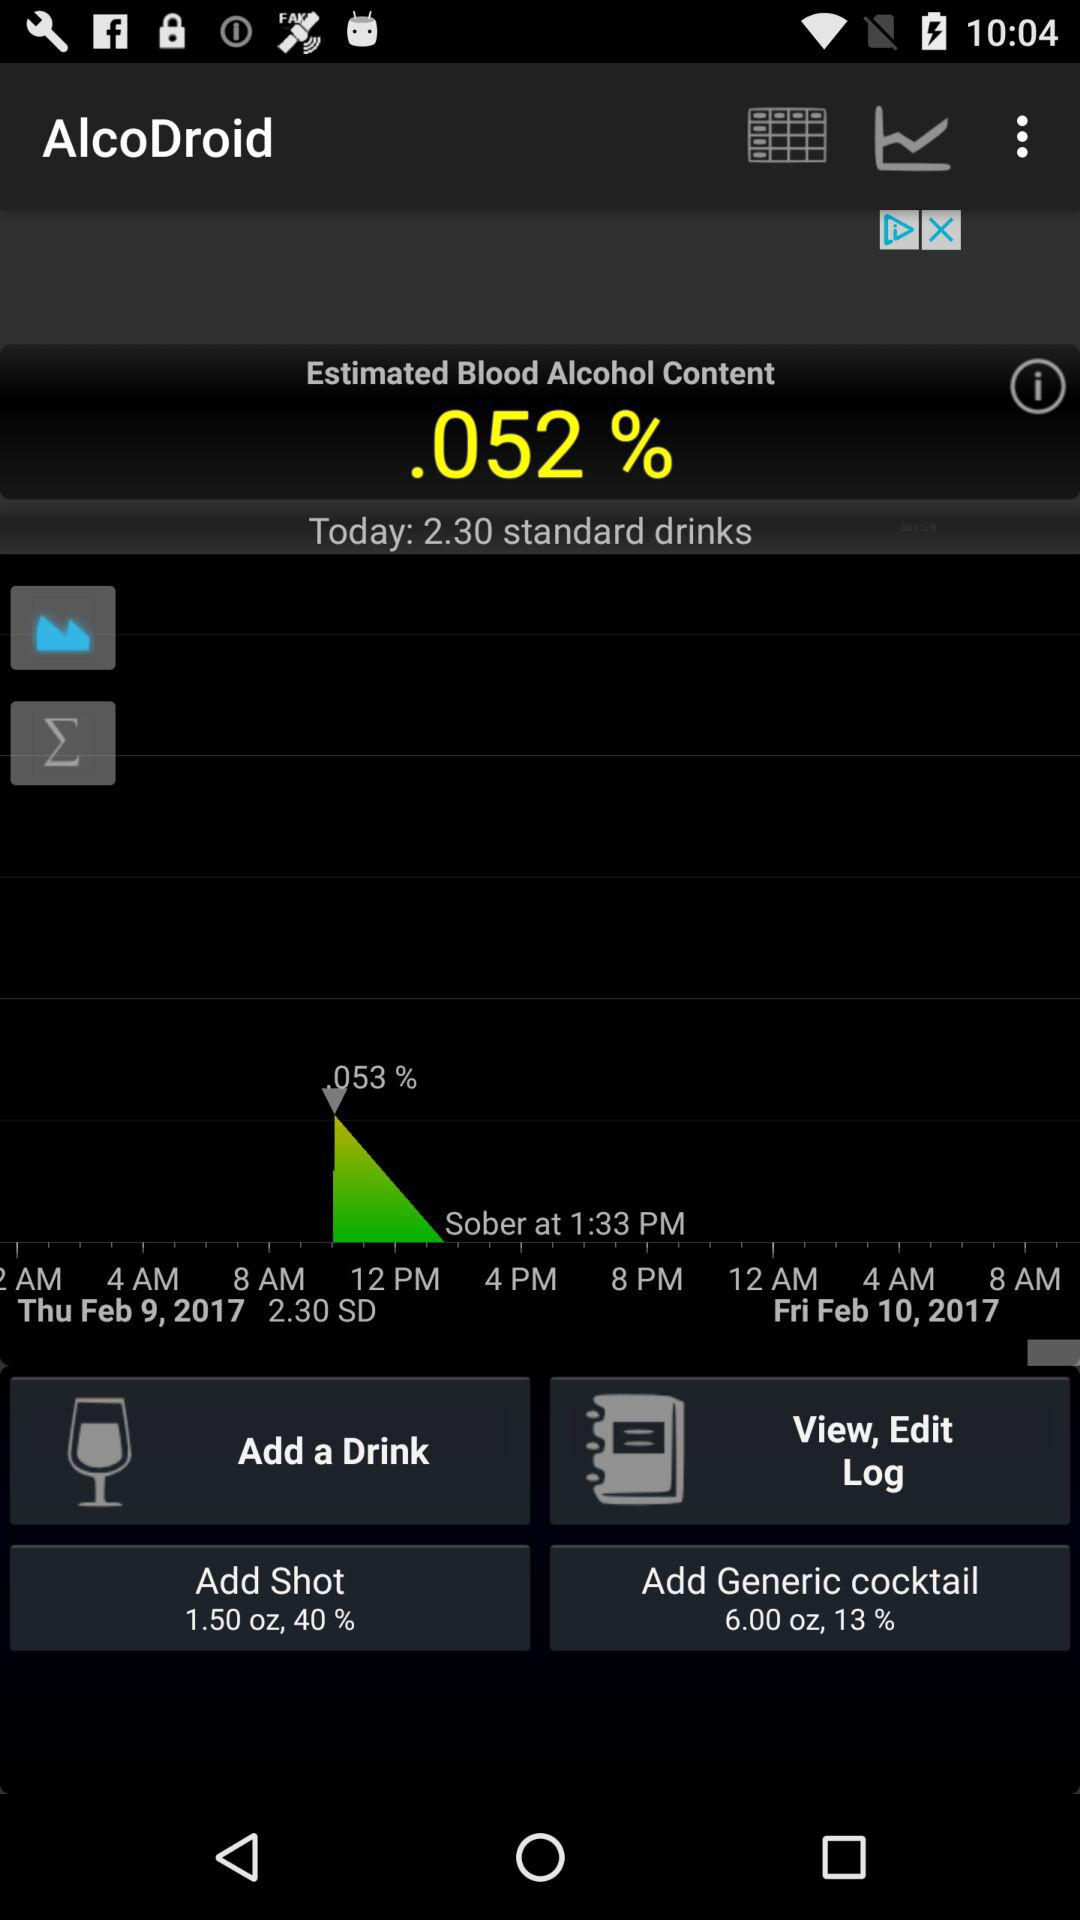What is the percentage of sober?
When the provided information is insufficient, respond with <no answer>. <no answer> 